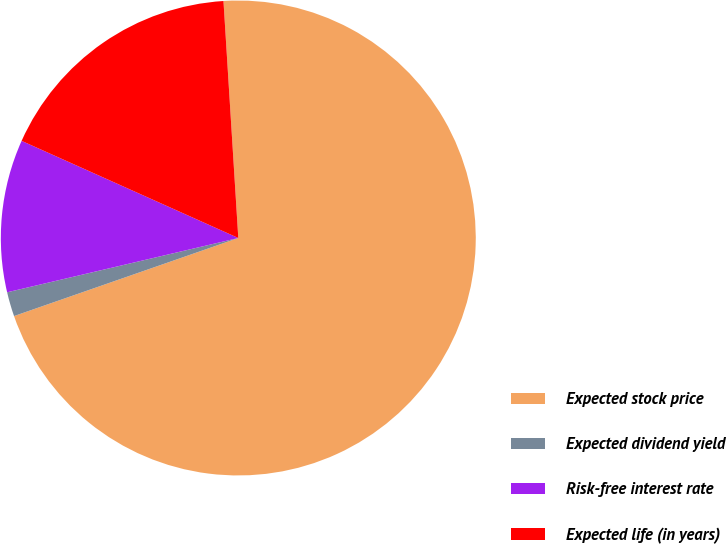<chart> <loc_0><loc_0><loc_500><loc_500><pie_chart><fcel>Expected stock price<fcel>Expected dividend yield<fcel>Risk-free interest rate<fcel>Expected life (in years)<nl><fcel>70.67%<fcel>1.66%<fcel>10.38%<fcel>17.3%<nl></chart> 